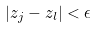Convert formula to latex. <formula><loc_0><loc_0><loc_500><loc_500>| z _ { j } - z _ { l } | < \epsilon</formula> 